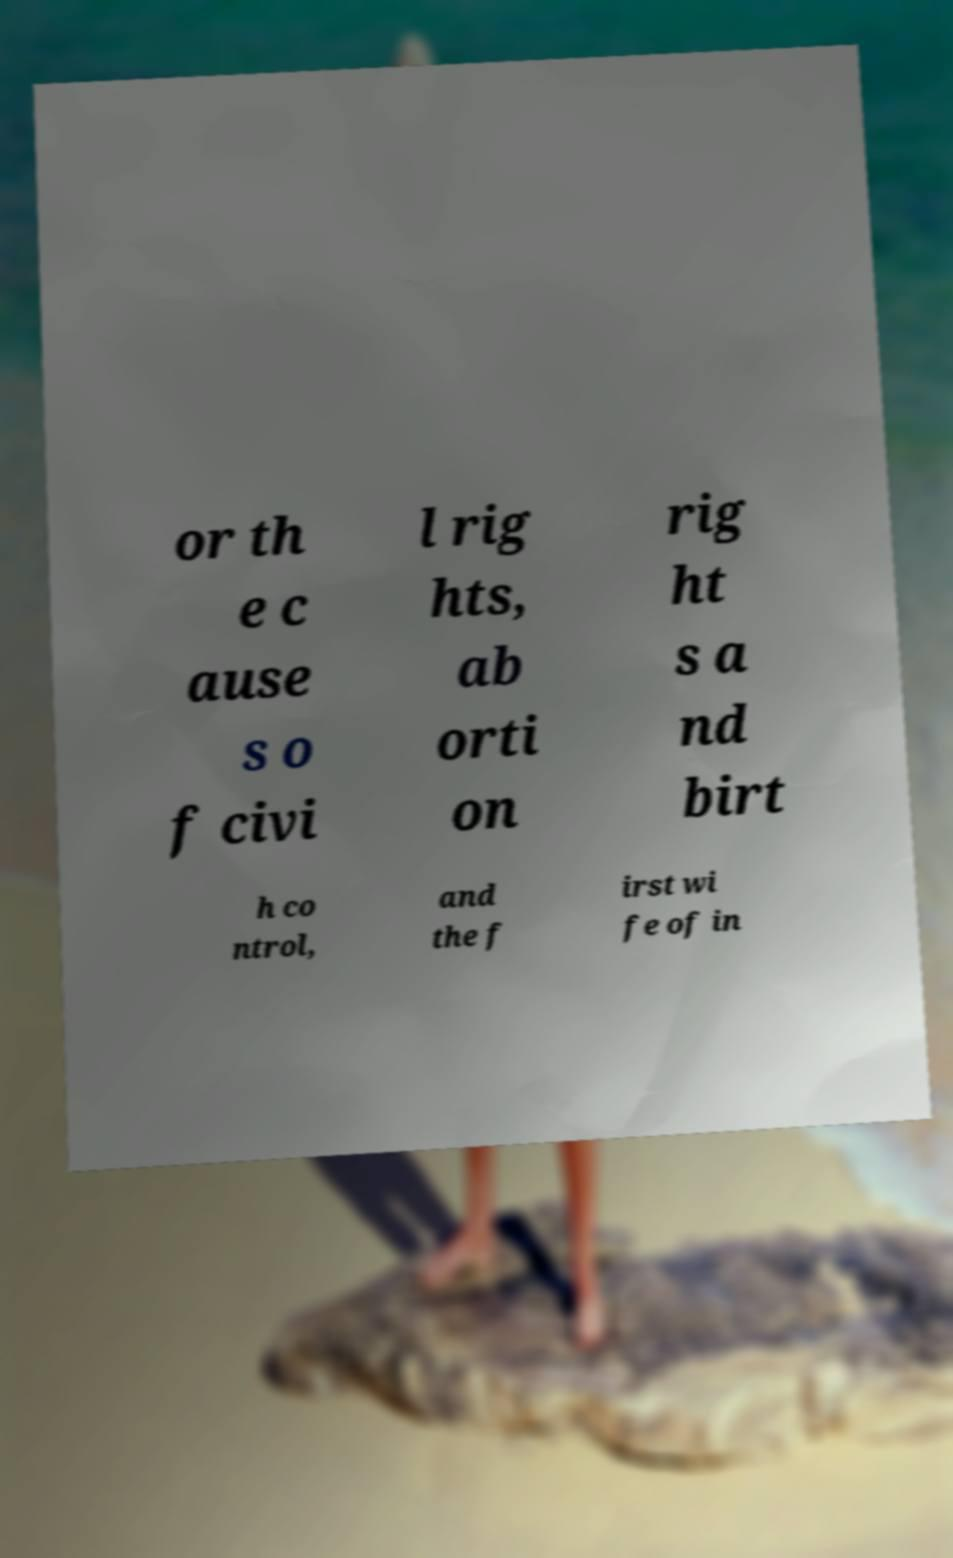For documentation purposes, I need the text within this image transcribed. Could you provide that? or th e c ause s o f civi l rig hts, ab orti on rig ht s a nd birt h co ntrol, and the f irst wi fe of in 